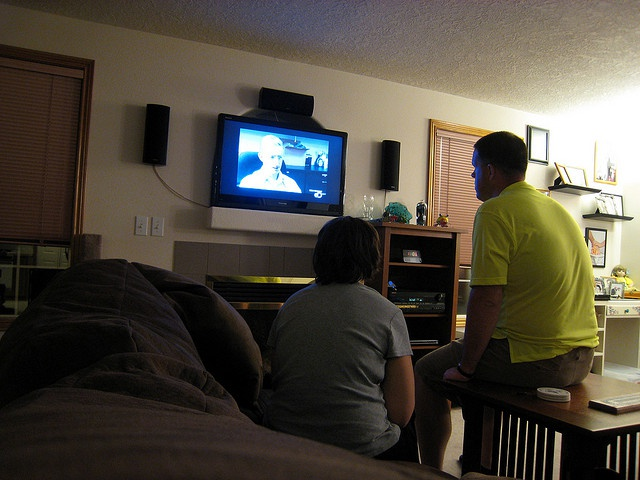Describe the objects in this image and their specific colors. I can see couch in black and gray tones, people in black and olive tones, people in black, gray, and maroon tones, tv in black, white, blue, and darkblue tones, and dining table in black, tan, and maroon tones in this image. 